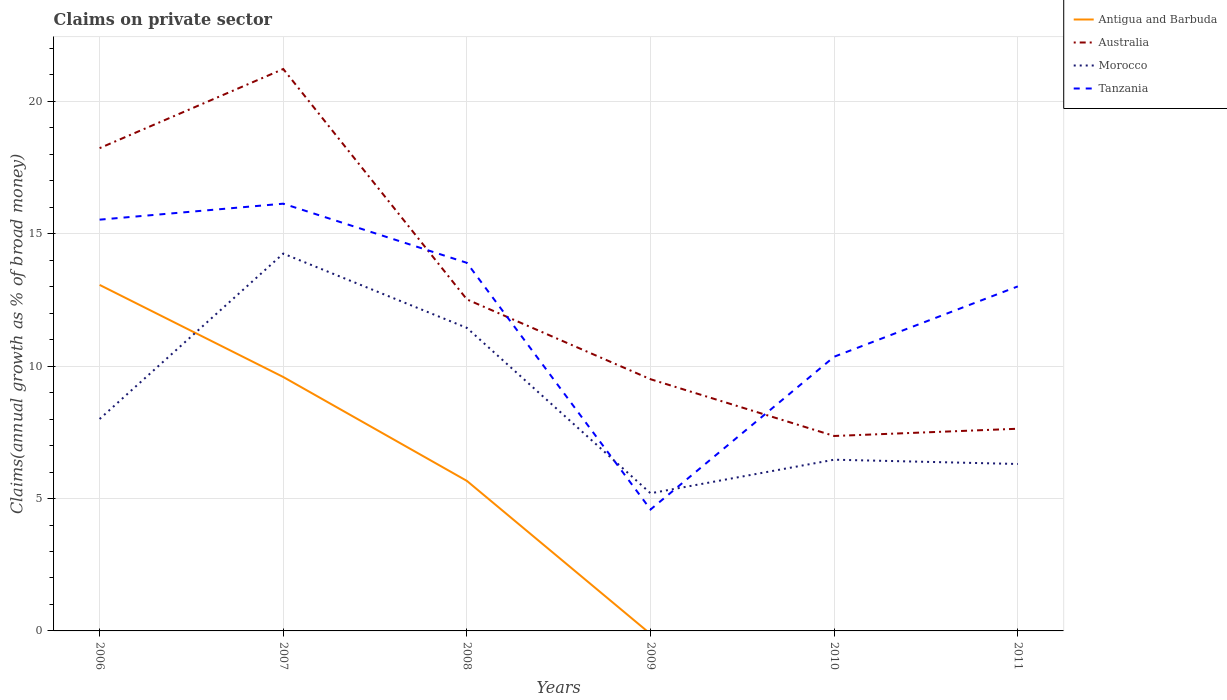What is the total percentage of broad money claimed on private sector in Australia in the graph?
Your response must be concise. 8.7. What is the difference between the highest and the second highest percentage of broad money claimed on private sector in Australia?
Your response must be concise. 13.86. What is the difference between the highest and the lowest percentage of broad money claimed on private sector in Australia?
Offer a terse response. 2. How many lines are there?
Your response must be concise. 4. What is the difference between two consecutive major ticks on the Y-axis?
Keep it short and to the point. 5. How many legend labels are there?
Give a very brief answer. 4. How are the legend labels stacked?
Make the answer very short. Vertical. What is the title of the graph?
Give a very brief answer. Claims on private sector. What is the label or title of the Y-axis?
Offer a terse response. Claims(annual growth as % of broad money). What is the Claims(annual growth as % of broad money) in Antigua and Barbuda in 2006?
Keep it short and to the point. 13.07. What is the Claims(annual growth as % of broad money) in Australia in 2006?
Offer a terse response. 18.23. What is the Claims(annual growth as % of broad money) of Morocco in 2006?
Offer a terse response. 8. What is the Claims(annual growth as % of broad money) of Tanzania in 2006?
Provide a succinct answer. 15.53. What is the Claims(annual growth as % of broad money) of Antigua and Barbuda in 2007?
Make the answer very short. 9.59. What is the Claims(annual growth as % of broad money) of Australia in 2007?
Provide a succinct answer. 21.22. What is the Claims(annual growth as % of broad money) of Morocco in 2007?
Offer a terse response. 14.25. What is the Claims(annual growth as % of broad money) of Tanzania in 2007?
Provide a succinct answer. 16.14. What is the Claims(annual growth as % of broad money) in Antigua and Barbuda in 2008?
Provide a succinct answer. 5.67. What is the Claims(annual growth as % of broad money) of Australia in 2008?
Offer a very short reply. 12.52. What is the Claims(annual growth as % of broad money) of Morocco in 2008?
Your answer should be compact. 11.45. What is the Claims(annual growth as % of broad money) in Tanzania in 2008?
Your response must be concise. 13.9. What is the Claims(annual growth as % of broad money) in Antigua and Barbuda in 2009?
Provide a short and direct response. 0. What is the Claims(annual growth as % of broad money) in Australia in 2009?
Your response must be concise. 9.51. What is the Claims(annual growth as % of broad money) of Morocco in 2009?
Provide a short and direct response. 5.2. What is the Claims(annual growth as % of broad money) in Tanzania in 2009?
Offer a very short reply. 4.59. What is the Claims(annual growth as % of broad money) in Antigua and Barbuda in 2010?
Provide a short and direct response. 0. What is the Claims(annual growth as % of broad money) of Australia in 2010?
Ensure brevity in your answer.  7.36. What is the Claims(annual growth as % of broad money) of Morocco in 2010?
Make the answer very short. 6.47. What is the Claims(annual growth as % of broad money) in Tanzania in 2010?
Your answer should be very brief. 10.36. What is the Claims(annual growth as % of broad money) of Antigua and Barbuda in 2011?
Keep it short and to the point. 0. What is the Claims(annual growth as % of broad money) of Australia in 2011?
Keep it short and to the point. 7.64. What is the Claims(annual growth as % of broad money) in Morocco in 2011?
Your answer should be very brief. 6.31. What is the Claims(annual growth as % of broad money) in Tanzania in 2011?
Your answer should be very brief. 13.01. Across all years, what is the maximum Claims(annual growth as % of broad money) in Antigua and Barbuda?
Provide a succinct answer. 13.07. Across all years, what is the maximum Claims(annual growth as % of broad money) of Australia?
Your answer should be compact. 21.22. Across all years, what is the maximum Claims(annual growth as % of broad money) in Morocco?
Ensure brevity in your answer.  14.25. Across all years, what is the maximum Claims(annual growth as % of broad money) in Tanzania?
Give a very brief answer. 16.14. Across all years, what is the minimum Claims(annual growth as % of broad money) in Australia?
Your answer should be compact. 7.36. Across all years, what is the minimum Claims(annual growth as % of broad money) in Morocco?
Offer a terse response. 5.2. Across all years, what is the minimum Claims(annual growth as % of broad money) of Tanzania?
Give a very brief answer. 4.59. What is the total Claims(annual growth as % of broad money) of Antigua and Barbuda in the graph?
Your answer should be compact. 28.33. What is the total Claims(annual growth as % of broad money) of Australia in the graph?
Your answer should be compact. 76.48. What is the total Claims(annual growth as % of broad money) in Morocco in the graph?
Your answer should be compact. 51.67. What is the total Claims(annual growth as % of broad money) in Tanzania in the graph?
Your answer should be compact. 73.53. What is the difference between the Claims(annual growth as % of broad money) of Antigua and Barbuda in 2006 and that in 2007?
Your answer should be very brief. 3.48. What is the difference between the Claims(annual growth as % of broad money) in Australia in 2006 and that in 2007?
Ensure brevity in your answer.  -2.99. What is the difference between the Claims(annual growth as % of broad money) in Morocco in 2006 and that in 2007?
Your answer should be very brief. -6.25. What is the difference between the Claims(annual growth as % of broad money) of Tanzania in 2006 and that in 2007?
Your answer should be very brief. -0.6. What is the difference between the Claims(annual growth as % of broad money) of Antigua and Barbuda in 2006 and that in 2008?
Keep it short and to the point. 7.4. What is the difference between the Claims(annual growth as % of broad money) in Australia in 2006 and that in 2008?
Ensure brevity in your answer.  5.71. What is the difference between the Claims(annual growth as % of broad money) in Morocco in 2006 and that in 2008?
Provide a short and direct response. -3.44. What is the difference between the Claims(annual growth as % of broad money) of Tanzania in 2006 and that in 2008?
Your response must be concise. 1.63. What is the difference between the Claims(annual growth as % of broad money) in Australia in 2006 and that in 2009?
Your response must be concise. 8.73. What is the difference between the Claims(annual growth as % of broad money) in Morocco in 2006 and that in 2009?
Ensure brevity in your answer.  2.81. What is the difference between the Claims(annual growth as % of broad money) in Tanzania in 2006 and that in 2009?
Offer a very short reply. 10.95. What is the difference between the Claims(annual growth as % of broad money) in Australia in 2006 and that in 2010?
Your answer should be very brief. 10.87. What is the difference between the Claims(annual growth as % of broad money) in Morocco in 2006 and that in 2010?
Your answer should be very brief. 1.54. What is the difference between the Claims(annual growth as % of broad money) of Tanzania in 2006 and that in 2010?
Keep it short and to the point. 5.18. What is the difference between the Claims(annual growth as % of broad money) of Australia in 2006 and that in 2011?
Your response must be concise. 10.6. What is the difference between the Claims(annual growth as % of broad money) of Morocco in 2006 and that in 2011?
Your answer should be very brief. 1.7. What is the difference between the Claims(annual growth as % of broad money) of Tanzania in 2006 and that in 2011?
Make the answer very short. 2.52. What is the difference between the Claims(annual growth as % of broad money) in Antigua and Barbuda in 2007 and that in 2008?
Your answer should be compact. 3.92. What is the difference between the Claims(annual growth as % of broad money) in Australia in 2007 and that in 2008?
Ensure brevity in your answer.  8.7. What is the difference between the Claims(annual growth as % of broad money) of Morocco in 2007 and that in 2008?
Ensure brevity in your answer.  2.81. What is the difference between the Claims(annual growth as % of broad money) of Tanzania in 2007 and that in 2008?
Offer a terse response. 2.23. What is the difference between the Claims(annual growth as % of broad money) in Australia in 2007 and that in 2009?
Your response must be concise. 11.72. What is the difference between the Claims(annual growth as % of broad money) in Morocco in 2007 and that in 2009?
Provide a short and direct response. 9.05. What is the difference between the Claims(annual growth as % of broad money) in Tanzania in 2007 and that in 2009?
Offer a very short reply. 11.55. What is the difference between the Claims(annual growth as % of broad money) in Australia in 2007 and that in 2010?
Your answer should be compact. 13.86. What is the difference between the Claims(annual growth as % of broad money) in Morocco in 2007 and that in 2010?
Your answer should be very brief. 7.78. What is the difference between the Claims(annual growth as % of broad money) in Tanzania in 2007 and that in 2010?
Keep it short and to the point. 5.78. What is the difference between the Claims(annual growth as % of broad money) in Australia in 2007 and that in 2011?
Provide a short and direct response. 13.59. What is the difference between the Claims(annual growth as % of broad money) of Morocco in 2007 and that in 2011?
Provide a short and direct response. 7.95. What is the difference between the Claims(annual growth as % of broad money) of Tanzania in 2007 and that in 2011?
Give a very brief answer. 3.12. What is the difference between the Claims(annual growth as % of broad money) of Australia in 2008 and that in 2009?
Your answer should be compact. 3.01. What is the difference between the Claims(annual growth as % of broad money) in Morocco in 2008 and that in 2009?
Give a very brief answer. 6.25. What is the difference between the Claims(annual growth as % of broad money) of Tanzania in 2008 and that in 2009?
Provide a short and direct response. 9.32. What is the difference between the Claims(annual growth as % of broad money) in Australia in 2008 and that in 2010?
Give a very brief answer. 5.16. What is the difference between the Claims(annual growth as % of broad money) in Morocco in 2008 and that in 2010?
Ensure brevity in your answer.  4.98. What is the difference between the Claims(annual growth as % of broad money) in Tanzania in 2008 and that in 2010?
Provide a succinct answer. 3.55. What is the difference between the Claims(annual growth as % of broad money) in Australia in 2008 and that in 2011?
Provide a short and direct response. 4.88. What is the difference between the Claims(annual growth as % of broad money) in Morocco in 2008 and that in 2011?
Offer a terse response. 5.14. What is the difference between the Claims(annual growth as % of broad money) in Tanzania in 2008 and that in 2011?
Offer a terse response. 0.89. What is the difference between the Claims(annual growth as % of broad money) of Australia in 2009 and that in 2010?
Your response must be concise. 2.14. What is the difference between the Claims(annual growth as % of broad money) in Morocco in 2009 and that in 2010?
Give a very brief answer. -1.27. What is the difference between the Claims(annual growth as % of broad money) of Tanzania in 2009 and that in 2010?
Make the answer very short. -5.77. What is the difference between the Claims(annual growth as % of broad money) in Australia in 2009 and that in 2011?
Your response must be concise. 1.87. What is the difference between the Claims(annual growth as % of broad money) of Morocco in 2009 and that in 2011?
Provide a short and direct response. -1.11. What is the difference between the Claims(annual growth as % of broad money) of Tanzania in 2009 and that in 2011?
Offer a terse response. -8.43. What is the difference between the Claims(annual growth as % of broad money) in Australia in 2010 and that in 2011?
Your answer should be compact. -0.27. What is the difference between the Claims(annual growth as % of broad money) of Morocco in 2010 and that in 2011?
Make the answer very short. 0.16. What is the difference between the Claims(annual growth as % of broad money) of Tanzania in 2010 and that in 2011?
Your answer should be compact. -2.66. What is the difference between the Claims(annual growth as % of broad money) in Antigua and Barbuda in 2006 and the Claims(annual growth as % of broad money) in Australia in 2007?
Give a very brief answer. -8.15. What is the difference between the Claims(annual growth as % of broad money) in Antigua and Barbuda in 2006 and the Claims(annual growth as % of broad money) in Morocco in 2007?
Ensure brevity in your answer.  -1.18. What is the difference between the Claims(annual growth as % of broad money) of Antigua and Barbuda in 2006 and the Claims(annual growth as % of broad money) of Tanzania in 2007?
Your answer should be compact. -3.07. What is the difference between the Claims(annual growth as % of broad money) of Australia in 2006 and the Claims(annual growth as % of broad money) of Morocco in 2007?
Keep it short and to the point. 3.98. What is the difference between the Claims(annual growth as % of broad money) of Australia in 2006 and the Claims(annual growth as % of broad money) of Tanzania in 2007?
Your answer should be very brief. 2.1. What is the difference between the Claims(annual growth as % of broad money) of Morocco in 2006 and the Claims(annual growth as % of broad money) of Tanzania in 2007?
Provide a succinct answer. -8.13. What is the difference between the Claims(annual growth as % of broad money) of Antigua and Barbuda in 2006 and the Claims(annual growth as % of broad money) of Australia in 2008?
Make the answer very short. 0.55. What is the difference between the Claims(annual growth as % of broad money) of Antigua and Barbuda in 2006 and the Claims(annual growth as % of broad money) of Morocco in 2008?
Your answer should be very brief. 1.62. What is the difference between the Claims(annual growth as % of broad money) in Antigua and Barbuda in 2006 and the Claims(annual growth as % of broad money) in Tanzania in 2008?
Make the answer very short. -0.83. What is the difference between the Claims(annual growth as % of broad money) of Australia in 2006 and the Claims(annual growth as % of broad money) of Morocco in 2008?
Your answer should be compact. 6.79. What is the difference between the Claims(annual growth as % of broad money) of Australia in 2006 and the Claims(annual growth as % of broad money) of Tanzania in 2008?
Ensure brevity in your answer.  4.33. What is the difference between the Claims(annual growth as % of broad money) of Morocco in 2006 and the Claims(annual growth as % of broad money) of Tanzania in 2008?
Your answer should be compact. -5.9. What is the difference between the Claims(annual growth as % of broad money) of Antigua and Barbuda in 2006 and the Claims(annual growth as % of broad money) of Australia in 2009?
Offer a terse response. 3.56. What is the difference between the Claims(annual growth as % of broad money) in Antigua and Barbuda in 2006 and the Claims(annual growth as % of broad money) in Morocco in 2009?
Keep it short and to the point. 7.87. What is the difference between the Claims(annual growth as % of broad money) in Antigua and Barbuda in 2006 and the Claims(annual growth as % of broad money) in Tanzania in 2009?
Ensure brevity in your answer.  8.48. What is the difference between the Claims(annual growth as % of broad money) of Australia in 2006 and the Claims(annual growth as % of broad money) of Morocco in 2009?
Ensure brevity in your answer.  13.04. What is the difference between the Claims(annual growth as % of broad money) in Australia in 2006 and the Claims(annual growth as % of broad money) in Tanzania in 2009?
Keep it short and to the point. 13.65. What is the difference between the Claims(annual growth as % of broad money) in Morocco in 2006 and the Claims(annual growth as % of broad money) in Tanzania in 2009?
Offer a very short reply. 3.42. What is the difference between the Claims(annual growth as % of broad money) in Antigua and Barbuda in 2006 and the Claims(annual growth as % of broad money) in Australia in 2010?
Your answer should be very brief. 5.71. What is the difference between the Claims(annual growth as % of broad money) of Antigua and Barbuda in 2006 and the Claims(annual growth as % of broad money) of Morocco in 2010?
Provide a short and direct response. 6.6. What is the difference between the Claims(annual growth as % of broad money) of Antigua and Barbuda in 2006 and the Claims(annual growth as % of broad money) of Tanzania in 2010?
Offer a terse response. 2.71. What is the difference between the Claims(annual growth as % of broad money) of Australia in 2006 and the Claims(annual growth as % of broad money) of Morocco in 2010?
Offer a terse response. 11.77. What is the difference between the Claims(annual growth as % of broad money) of Australia in 2006 and the Claims(annual growth as % of broad money) of Tanzania in 2010?
Provide a succinct answer. 7.88. What is the difference between the Claims(annual growth as % of broad money) in Morocco in 2006 and the Claims(annual growth as % of broad money) in Tanzania in 2010?
Give a very brief answer. -2.35. What is the difference between the Claims(annual growth as % of broad money) in Antigua and Barbuda in 2006 and the Claims(annual growth as % of broad money) in Australia in 2011?
Make the answer very short. 5.43. What is the difference between the Claims(annual growth as % of broad money) in Antigua and Barbuda in 2006 and the Claims(annual growth as % of broad money) in Morocco in 2011?
Offer a very short reply. 6.76. What is the difference between the Claims(annual growth as % of broad money) in Antigua and Barbuda in 2006 and the Claims(annual growth as % of broad money) in Tanzania in 2011?
Provide a succinct answer. 0.06. What is the difference between the Claims(annual growth as % of broad money) of Australia in 2006 and the Claims(annual growth as % of broad money) of Morocco in 2011?
Provide a succinct answer. 11.93. What is the difference between the Claims(annual growth as % of broad money) of Australia in 2006 and the Claims(annual growth as % of broad money) of Tanzania in 2011?
Ensure brevity in your answer.  5.22. What is the difference between the Claims(annual growth as % of broad money) of Morocco in 2006 and the Claims(annual growth as % of broad money) of Tanzania in 2011?
Give a very brief answer. -5.01. What is the difference between the Claims(annual growth as % of broad money) of Antigua and Barbuda in 2007 and the Claims(annual growth as % of broad money) of Australia in 2008?
Your answer should be very brief. -2.93. What is the difference between the Claims(annual growth as % of broad money) of Antigua and Barbuda in 2007 and the Claims(annual growth as % of broad money) of Morocco in 2008?
Give a very brief answer. -1.86. What is the difference between the Claims(annual growth as % of broad money) in Antigua and Barbuda in 2007 and the Claims(annual growth as % of broad money) in Tanzania in 2008?
Offer a terse response. -4.31. What is the difference between the Claims(annual growth as % of broad money) of Australia in 2007 and the Claims(annual growth as % of broad money) of Morocco in 2008?
Give a very brief answer. 9.78. What is the difference between the Claims(annual growth as % of broad money) in Australia in 2007 and the Claims(annual growth as % of broad money) in Tanzania in 2008?
Keep it short and to the point. 7.32. What is the difference between the Claims(annual growth as % of broad money) of Morocco in 2007 and the Claims(annual growth as % of broad money) of Tanzania in 2008?
Your response must be concise. 0.35. What is the difference between the Claims(annual growth as % of broad money) in Antigua and Barbuda in 2007 and the Claims(annual growth as % of broad money) in Australia in 2009?
Provide a short and direct response. 0.08. What is the difference between the Claims(annual growth as % of broad money) in Antigua and Barbuda in 2007 and the Claims(annual growth as % of broad money) in Morocco in 2009?
Your response must be concise. 4.39. What is the difference between the Claims(annual growth as % of broad money) in Antigua and Barbuda in 2007 and the Claims(annual growth as % of broad money) in Tanzania in 2009?
Give a very brief answer. 5. What is the difference between the Claims(annual growth as % of broad money) in Australia in 2007 and the Claims(annual growth as % of broad money) in Morocco in 2009?
Make the answer very short. 16.02. What is the difference between the Claims(annual growth as % of broad money) in Australia in 2007 and the Claims(annual growth as % of broad money) in Tanzania in 2009?
Provide a short and direct response. 16.64. What is the difference between the Claims(annual growth as % of broad money) in Morocco in 2007 and the Claims(annual growth as % of broad money) in Tanzania in 2009?
Provide a short and direct response. 9.67. What is the difference between the Claims(annual growth as % of broad money) of Antigua and Barbuda in 2007 and the Claims(annual growth as % of broad money) of Australia in 2010?
Make the answer very short. 2.23. What is the difference between the Claims(annual growth as % of broad money) in Antigua and Barbuda in 2007 and the Claims(annual growth as % of broad money) in Morocco in 2010?
Provide a short and direct response. 3.12. What is the difference between the Claims(annual growth as % of broad money) of Antigua and Barbuda in 2007 and the Claims(annual growth as % of broad money) of Tanzania in 2010?
Offer a terse response. -0.77. What is the difference between the Claims(annual growth as % of broad money) in Australia in 2007 and the Claims(annual growth as % of broad money) in Morocco in 2010?
Ensure brevity in your answer.  14.76. What is the difference between the Claims(annual growth as % of broad money) of Australia in 2007 and the Claims(annual growth as % of broad money) of Tanzania in 2010?
Your answer should be very brief. 10.87. What is the difference between the Claims(annual growth as % of broad money) of Morocco in 2007 and the Claims(annual growth as % of broad money) of Tanzania in 2010?
Make the answer very short. 3.89. What is the difference between the Claims(annual growth as % of broad money) of Antigua and Barbuda in 2007 and the Claims(annual growth as % of broad money) of Australia in 2011?
Ensure brevity in your answer.  1.95. What is the difference between the Claims(annual growth as % of broad money) of Antigua and Barbuda in 2007 and the Claims(annual growth as % of broad money) of Morocco in 2011?
Keep it short and to the point. 3.29. What is the difference between the Claims(annual growth as % of broad money) of Antigua and Barbuda in 2007 and the Claims(annual growth as % of broad money) of Tanzania in 2011?
Offer a very short reply. -3.42. What is the difference between the Claims(annual growth as % of broad money) of Australia in 2007 and the Claims(annual growth as % of broad money) of Morocco in 2011?
Offer a very short reply. 14.92. What is the difference between the Claims(annual growth as % of broad money) in Australia in 2007 and the Claims(annual growth as % of broad money) in Tanzania in 2011?
Provide a succinct answer. 8.21. What is the difference between the Claims(annual growth as % of broad money) in Morocco in 2007 and the Claims(annual growth as % of broad money) in Tanzania in 2011?
Provide a succinct answer. 1.24. What is the difference between the Claims(annual growth as % of broad money) of Antigua and Barbuda in 2008 and the Claims(annual growth as % of broad money) of Australia in 2009?
Provide a succinct answer. -3.84. What is the difference between the Claims(annual growth as % of broad money) in Antigua and Barbuda in 2008 and the Claims(annual growth as % of broad money) in Morocco in 2009?
Your response must be concise. 0.47. What is the difference between the Claims(annual growth as % of broad money) in Antigua and Barbuda in 2008 and the Claims(annual growth as % of broad money) in Tanzania in 2009?
Your answer should be very brief. 1.08. What is the difference between the Claims(annual growth as % of broad money) of Australia in 2008 and the Claims(annual growth as % of broad money) of Morocco in 2009?
Keep it short and to the point. 7.32. What is the difference between the Claims(annual growth as % of broad money) of Australia in 2008 and the Claims(annual growth as % of broad money) of Tanzania in 2009?
Provide a succinct answer. 7.94. What is the difference between the Claims(annual growth as % of broad money) of Morocco in 2008 and the Claims(annual growth as % of broad money) of Tanzania in 2009?
Provide a short and direct response. 6.86. What is the difference between the Claims(annual growth as % of broad money) of Antigua and Barbuda in 2008 and the Claims(annual growth as % of broad money) of Australia in 2010?
Ensure brevity in your answer.  -1.7. What is the difference between the Claims(annual growth as % of broad money) in Antigua and Barbuda in 2008 and the Claims(annual growth as % of broad money) in Morocco in 2010?
Ensure brevity in your answer.  -0.8. What is the difference between the Claims(annual growth as % of broad money) of Antigua and Barbuda in 2008 and the Claims(annual growth as % of broad money) of Tanzania in 2010?
Your answer should be very brief. -4.69. What is the difference between the Claims(annual growth as % of broad money) of Australia in 2008 and the Claims(annual growth as % of broad money) of Morocco in 2010?
Keep it short and to the point. 6.05. What is the difference between the Claims(annual growth as % of broad money) in Australia in 2008 and the Claims(annual growth as % of broad money) in Tanzania in 2010?
Provide a short and direct response. 2.16. What is the difference between the Claims(annual growth as % of broad money) in Morocco in 2008 and the Claims(annual growth as % of broad money) in Tanzania in 2010?
Provide a succinct answer. 1.09. What is the difference between the Claims(annual growth as % of broad money) in Antigua and Barbuda in 2008 and the Claims(annual growth as % of broad money) in Australia in 2011?
Offer a very short reply. -1.97. What is the difference between the Claims(annual growth as % of broad money) in Antigua and Barbuda in 2008 and the Claims(annual growth as % of broad money) in Morocco in 2011?
Offer a very short reply. -0.64. What is the difference between the Claims(annual growth as % of broad money) of Antigua and Barbuda in 2008 and the Claims(annual growth as % of broad money) of Tanzania in 2011?
Offer a terse response. -7.35. What is the difference between the Claims(annual growth as % of broad money) of Australia in 2008 and the Claims(annual growth as % of broad money) of Morocco in 2011?
Your answer should be compact. 6.22. What is the difference between the Claims(annual growth as % of broad money) in Australia in 2008 and the Claims(annual growth as % of broad money) in Tanzania in 2011?
Your response must be concise. -0.49. What is the difference between the Claims(annual growth as % of broad money) of Morocco in 2008 and the Claims(annual growth as % of broad money) of Tanzania in 2011?
Give a very brief answer. -1.57. What is the difference between the Claims(annual growth as % of broad money) of Australia in 2009 and the Claims(annual growth as % of broad money) of Morocco in 2010?
Your answer should be very brief. 3.04. What is the difference between the Claims(annual growth as % of broad money) in Australia in 2009 and the Claims(annual growth as % of broad money) in Tanzania in 2010?
Offer a terse response. -0.85. What is the difference between the Claims(annual growth as % of broad money) of Morocco in 2009 and the Claims(annual growth as % of broad money) of Tanzania in 2010?
Your answer should be compact. -5.16. What is the difference between the Claims(annual growth as % of broad money) in Australia in 2009 and the Claims(annual growth as % of broad money) in Morocco in 2011?
Keep it short and to the point. 3.2. What is the difference between the Claims(annual growth as % of broad money) in Australia in 2009 and the Claims(annual growth as % of broad money) in Tanzania in 2011?
Offer a terse response. -3.51. What is the difference between the Claims(annual growth as % of broad money) in Morocco in 2009 and the Claims(annual growth as % of broad money) in Tanzania in 2011?
Offer a terse response. -7.81. What is the difference between the Claims(annual growth as % of broad money) in Australia in 2010 and the Claims(annual growth as % of broad money) in Morocco in 2011?
Your answer should be very brief. 1.06. What is the difference between the Claims(annual growth as % of broad money) in Australia in 2010 and the Claims(annual growth as % of broad money) in Tanzania in 2011?
Provide a short and direct response. -5.65. What is the difference between the Claims(annual growth as % of broad money) in Morocco in 2010 and the Claims(annual growth as % of broad money) in Tanzania in 2011?
Your answer should be compact. -6.55. What is the average Claims(annual growth as % of broad money) of Antigua and Barbuda per year?
Your answer should be very brief. 4.72. What is the average Claims(annual growth as % of broad money) of Australia per year?
Provide a short and direct response. 12.75. What is the average Claims(annual growth as % of broad money) of Morocco per year?
Your answer should be compact. 8.61. What is the average Claims(annual growth as % of broad money) of Tanzania per year?
Keep it short and to the point. 12.25. In the year 2006, what is the difference between the Claims(annual growth as % of broad money) in Antigua and Barbuda and Claims(annual growth as % of broad money) in Australia?
Keep it short and to the point. -5.17. In the year 2006, what is the difference between the Claims(annual growth as % of broad money) in Antigua and Barbuda and Claims(annual growth as % of broad money) in Morocco?
Offer a very short reply. 5.06. In the year 2006, what is the difference between the Claims(annual growth as % of broad money) in Antigua and Barbuda and Claims(annual growth as % of broad money) in Tanzania?
Offer a terse response. -2.46. In the year 2006, what is the difference between the Claims(annual growth as % of broad money) of Australia and Claims(annual growth as % of broad money) of Morocco?
Your answer should be compact. 10.23. In the year 2006, what is the difference between the Claims(annual growth as % of broad money) of Australia and Claims(annual growth as % of broad money) of Tanzania?
Ensure brevity in your answer.  2.7. In the year 2006, what is the difference between the Claims(annual growth as % of broad money) in Morocco and Claims(annual growth as % of broad money) in Tanzania?
Offer a very short reply. -7.53. In the year 2007, what is the difference between the Claims(annual growth as % of broad money) of Antigua and Barbuda and Claims(annual growth as % of broad money) of Australia?
Ensure brevity in your answer.  -11.63. In the year 2007, what is the difference between the Claims(annual growth as % of broad money) in Antigua and Barbuda and Claims(annual growth as % of broad money) in Morocco?
Offer a terse response. -4.66. In the year 2007, what is the difference between the Claims(annual growth as % of broad money) in Antigua and Barbuda and Claims(annual growth as % of broad money) in Tanzania?
Make the answer very short. -6.55. In the year 2007, what is the difference between the Claims(annual growth as % of broad money) of Australia and Claims(annual growth as % of broad money) of Morocco?
Provide a short and direct response. 6.97. In the year 2007, what is the difference between the Claims(annual growth as % of broad money) of Australia and Claims(annual growth as % of broad money) of Tanzania?
Make the answer very short. 5.09. In the year 2007, what is the difference between the Claims(annual growth as % of broad money) of Morocco and Claims(annual growth as % of broad money) of Tanzania?
Provide a succinct answer. -1.89. In the year 2008, what is the difference between the Claims(annual growth as % of broad money) in Antigua and Barbuda and Claims(annual growth as % of broad money) in Australia?
Offer a very short reply. -6.85. In the year 2008, what is the difference between the Claims(annual growth as % of broad money) of Antigua and Barbuda and Claims(annual growth as % of broad money) of Morocco?
Ensure brevity in your answer.  -5.78. In the year 2008, what is the difference between the Claims(annual growth as % of broad money) of Antigua and Barbuda and Claims(annual growth as % of broad money) of Tanzania?
Offer a very short reply. -8.24. In the year 2008, what is the difference between the Claims(annual growth as % of broad money) of Australia and Claims(annual growth as % of broad money) of Morocco?
Offer a terse response. 1.08. In the year 2008, what is the difference between the Claims(annual growth as % of broad money) in Australia and Claims(annual growth as % of broad money) in Tanzania?
Offer a very short reply. -1.38. In the year 2008, what is the difference between the Claims(annual growth as % of broad money) in Morocco and Claims(annual growth as % of broad money) in Tanzania?
Provide a succinct answer. -2.46. In the year 2009, what is the difference between the Claims(annual growth as % of broad money) of Australia and Claims(annual growth as % of broad money) of Morocco?
Your answer should be very brief. 4.31. In the year 2009, what is the difference between the Claims(annual growth as % of broad money) of Australia and Claims(annual growth as % of broad money) of Tanzania?
Your response must be concise. 4.92. In the year 2009, what is the difference between the Claims(annual growth as % of broad money) of Morocco and Claims(annual growth as % of broad money) of Tanzania?
Your answer should be very brief. 0.61. In the year 2010, what is the difference between the Claims(annual growth as % of broad money) in Australia and Claims(annual growth as % of broad money) in Morocco?
Provide a succinct answer. 0.9. In the year 2010, what is the difference between the Claims(annual growth as % of broad money) of Australia and Claims(annual growth as % of broad money) of Tanzania?
Offer a terse response. -2.99. In the year 2010, what is the difference between the Claims(annual growth as % of broad money) of Morocco and Claims(annual growth as % of broad money) of Tanzania?
Offer a terse response. -3.89. In the year 2011, what is the difference between the Claims(annual growth as % of broad money) of Australia and Claims(annual growth as % of broad money) of Morocco?
Keep it short and to the point. 1.33. In the year 2011, what is the difference between the Claims(annual growth as % of broad money) of Australia and Claims(annual growth as % of broad money) of Tanzania?
Offer a very short reply. -5.38. In the year 2011, what is the difference between the Claims(annual growth as % of broad money) in Morocco and Claims(annual growth as % of broad money) in Tanzania?
Your answer should be very brief. -6.71. What is the ratio of the Claims(annual growth as % of broad money) of Antigua and Barbuda in 2006 to that in 2007?
Make the answer very short. 1.36. What is the ratio of the Claims(annual growth as % of broad money) in Australia in 2006 to that in 2007?
Make the answer very short. 0.86. What is the ratio of the Claims(annual growth as % of broad money) in Morocco in 2006 to that in 2007?
Your response must be concise. 0.56. What is the ratio of the Claims(annual growth as % of broad money) in Tanzania in 2006 to that in 2007?
Make the answer very short. 0.96. What is the ratio of the Claims(annual growth as % of broad money) of Antigua and Barbuda in 2006 to that in 2008?
Your response must be concise. 2.31. What is the ratio of the Claims(annual growth as % of broad money) of Australia in 2006 to that in 2008?
Your answer should be compact. 1.46. What is the ratio of the Claims(annual growth as % of broad money) of Morocco in 2006 to that in 2008?
Give a very brief answer. 0.7. What is the ratio of the Claims(annual growth as % of broad money) of Tanzania in 2006 to that in 2008?
Offer a terse response. 1.12. What is the ratio of the Claims(annual growth as % of broad money) in Australia in 2006 to that in 2009?
Provide a succinct answer. 1.92. What is the ratio of the Claims(annual growth as % of broad money) in Morocco in 2006 to that in 2009?
Your response must be concise. 1.54. What is the ratio of the Claims(annual growth as % of broad money) of Tanzania in 2006 to that in 2009?
Offer a very short reply. 3.39. What is the ratio of the Claims(annual growth as % of broad money) in Australia in 2006 to that in 2010?
Offer a terse response. 2.48. What is the ratio of the Claims(annual growth as % of broad money) in Morocco in 2006 to that in 2010?
Offer a terse response. 1.24. What is the ratio of the Claims(annual growth as % of broad money) in Tanzania in 2006 to that in 2010?
Your response must be concise. 1.5. What is the ratio of the Claims(annual growth as % of broad money) of Australia in 2006 to that in 2011?
Make the answer very short. 2.39. What is the ratio of the Claims(annual growth as % of broad money) in Morocco in 2006 to that in 2011?
Keep it short and to the point. 1.27. What is the ratio of the Claims(annual growth as % of broad money) in Tanzania in 2006 to that in 2011?
Your response must be concise. 1.19. What is the ratio of the Claims(annual growth as % of broad money) in Antigua and Barbuda in 2007 to that in 2008?
Keep it short and to the point. 1.69. What is the ratio of the Claims(annual growth as % of broad money) in Australia in 2007 to that in 2008?
Offer a terse response. 1.7. What is the ratio of the Claims(annual growth as % of broad money) of Morocco in 2007 to that in 2008?
Offer a very short reply. 1.25. What is the ratio of the Claims(annual growth as % of broad money) of Tanzania in 2007 to that in 2008?
Offer a very short reply. 1.16. What is the ratio of the Claims(annual growth as % of broad money) of Australia in 2007 to that in 2009?
Provide a short and direct response. 2.23. What is the ratio of the Claims(annual growth as % of broad money) in Morocco in 2007 to that in 2009?
Your response must be concise. 2.74. What is the ratio of the Claims(annual growth as % of broad money) in Tanzania in 2007 to that in 2009?
Your answer should be very brief. 3.52. What is the ratio of the Claims(annual growth as % of broad money) in Australia in 2007 to that in 2010?
Your answer should be very brief. 2.88. What is the ratio of the Claims(annual growth as % of broad money) in Morocco in 2007 to that in 2010?
Your response must be concise. 2.2. What is the ratio of the Claims(annual growth as % of broad money) in Tanzania in 2007 to that in 2010?
Keep it short and to the point. 1.56. What is the ratio of the Claims(annual growth as % of broad money) of Australia in 2007 to that in 2011?
Give a very brief answer. 2.78. What is the ratio of the Claims(annual growth as % of broad money) in Morocco in 2007 to that in 2011?
Ensure brevity in your answer.  2.26. What is the ratio of the Claims(annual growth as % of broad money) of Tanzania in 2007 to that in 2011?
Offer a terse response. 1.24. What is the ratio of the Claims(annual growth as % of broad money) of Australia in 2008 to that in 2009?
Make the answer very short. 1.32. What is the ratio of the Claims(annual growth as % of broad money) of Morocco in 2008 to that in 2009?
Provide a succinct answer. 2.2. What is the ratio of the Claims(annual growth as % of broad money) in Tanzania in 2008 to that in 2009?
Provide a succinct answer. 3.03. What is the ratio of the Claims(annual growth as % of broad money) in Australia in 2008 to that in 2010?
Your response must be concise. 1.7. What is the ratio of the Claims(annual growth as % of broad money) of Morocco in 2008 to that in 2010?
Provide a succinct answer. 1.77. What is the ratio of the Claims(annual growth as % of broad money) of Tanzania in 2008 to that in 2010?
Provide a short and direct response. 1.34. What is the ratio of the Claims(annual growth as % of broad money) of Australia in 2008 to that in 2011?
Offer a very short reply. 1.64. What is the ratio of the Claims(annual growth as % of broad money) of Morocco in 2008 to that in 2011?
Offer a very short reply. 1.82. What is the ratio of the Claims(annual growth as % of broad money) of Tanzania in 2008 to that in 2011?
Provide a short and direct response. 1.07. What is the ratio of the Claims(annual growth as % of broad money) of Australia in 2009 to that in 2010?
Provide a short and direct response. 1.29. What is the ratio of the Claims(annual growth as % of broad money) in Morocco in 2009 to that in 2010?
Your response must be concise. 0.8. What is the ratio of the Claims(annual growth as % of broad money) in Tanzania in 2009 to that in 2010?
Ensure brevity in your answer.  0.44. What is the ratio of the Claims(annual growth as % of broad money) in Australia in 2009 to that in 2011?
Offer a very short reply. 1.24. What is the ratio of the Claims(annual growth as % of broad money) in Morocco in 2009 to that in 2011?
Offer a very short reply. 0.82. What is the ratio of the Claims(annual growth as % of broad money) in Tanzania in 2009 to that in 2011?
Make the answer very short. 0.35. What is the ratio of the Claims(annual growth as % of broad money) of Australia in 2010 to that in 2011?
Make the answer very short. 0.96. What is the ratio of the Claims(annual growth as % of broad money) of Morocco in 2010 to that in 2011?
Your answer should be very brief. 1.03. What is the ratio of the Claims(annual growth as % of broad money) in Tanzania in 2010 to that in 2011?
Your answer should be compact. 0.8. What is the difference between the highest and the second highest Claims(annual growth as % of broad money) in Antigua and Barbuda?
Ensure brevity in your answer.  3.48. What is the difference between the highest and the second highest Claims(annual growth as % of broad money) of Australia?
Give a very brief answer. 2.99. What is the difference between the highest and the second highest Claims(annual growth as % of broad money) of Morocco?
Make the answer very short. 2.81. What is the difference between the highest and the second highest Claims(annual growth as % of broad money) of Tanzania?
Make the answer very short. 0.6. What is the difference between the highest and the lowest Claims(annual growth as % of broad money) of Antigua and Barbuda?
Keep it short and to the point. 13.07. What is the difference between the highest and the lowest Claims(annual growth as % of broad money) in Australia?
Give a very brief answer. 13.86. What is the difference between the highest and the lowest Claims(annual growth as % of broad money) of Morocco?
Make the answer very short. 9.05. What is the difference between the highest and the lowest Claims(annual growth as % of broad money) in Tanzania?
Keep it short and to the point. 11.55. 